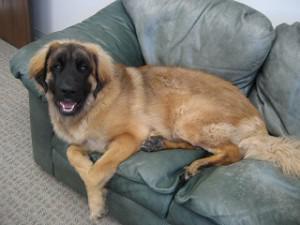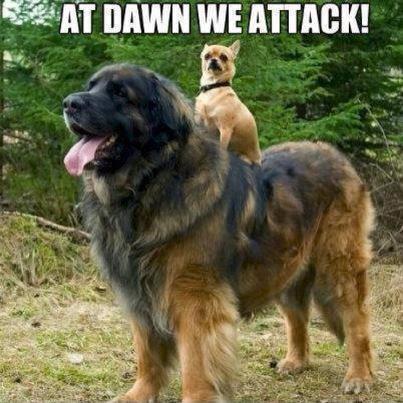The first image is the image on the left, the second image is the image on the right. Considering the images on both sides, is "The left photo depicts a puppy with its front paws propped up on something." valid? Answer yes or no. No. The first image is the image on the left, the second image is the image on the right. Evaluate the accuracy of this statement regarding the images: "A puppy sits upright with its front paws hanging over something else.". Is it true? Answer yes or no. No. 